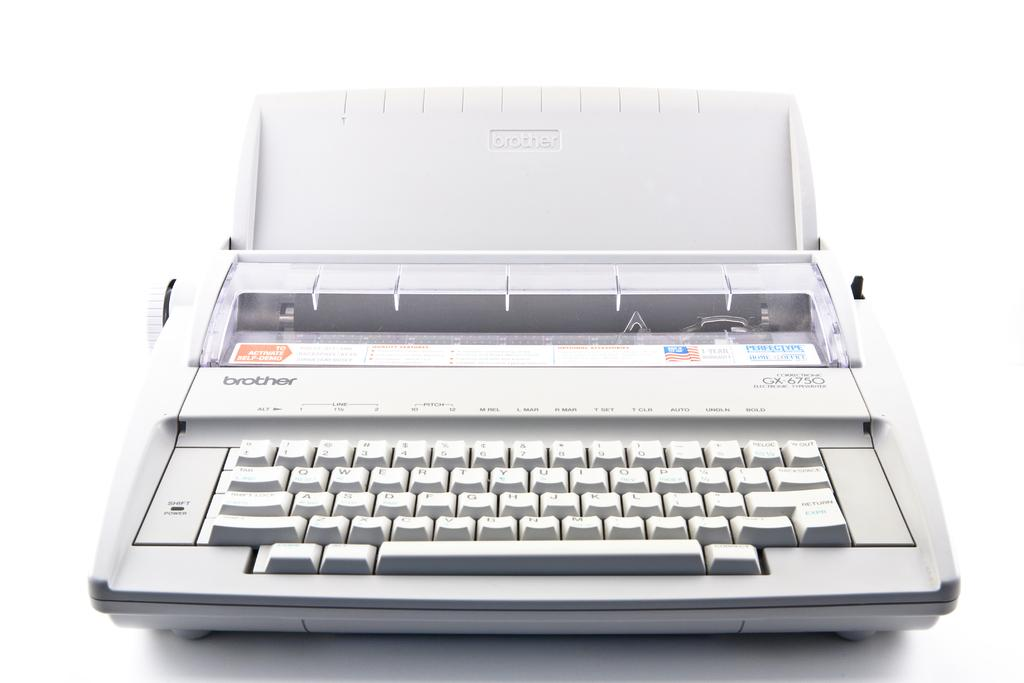<image>
Summarize the visual content of the image. A type writer made by the company Brother that is mostly white. 